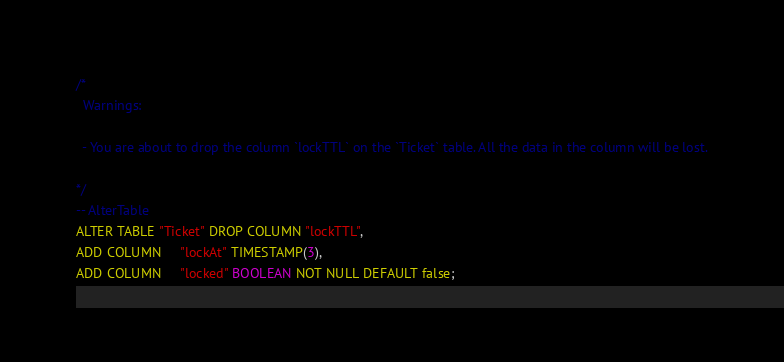<code> <loc_0><loc_0><loc_500><loc_500><_SQL_>/*
  Warnings:

  - You are about to drop the column `lockTTL` on the `Ticket` table. All the data in the column will be lost.

*/
-- AlterTable
ALTER TABLE "Ticket" DROP COLUMN "lockTTL",
ADD COLUMN     "lockAt" TIMESTAMP(3),
ADD COLUMN     "locked" BOOLEAN NOT NULL DEFAULT false;
</code> 